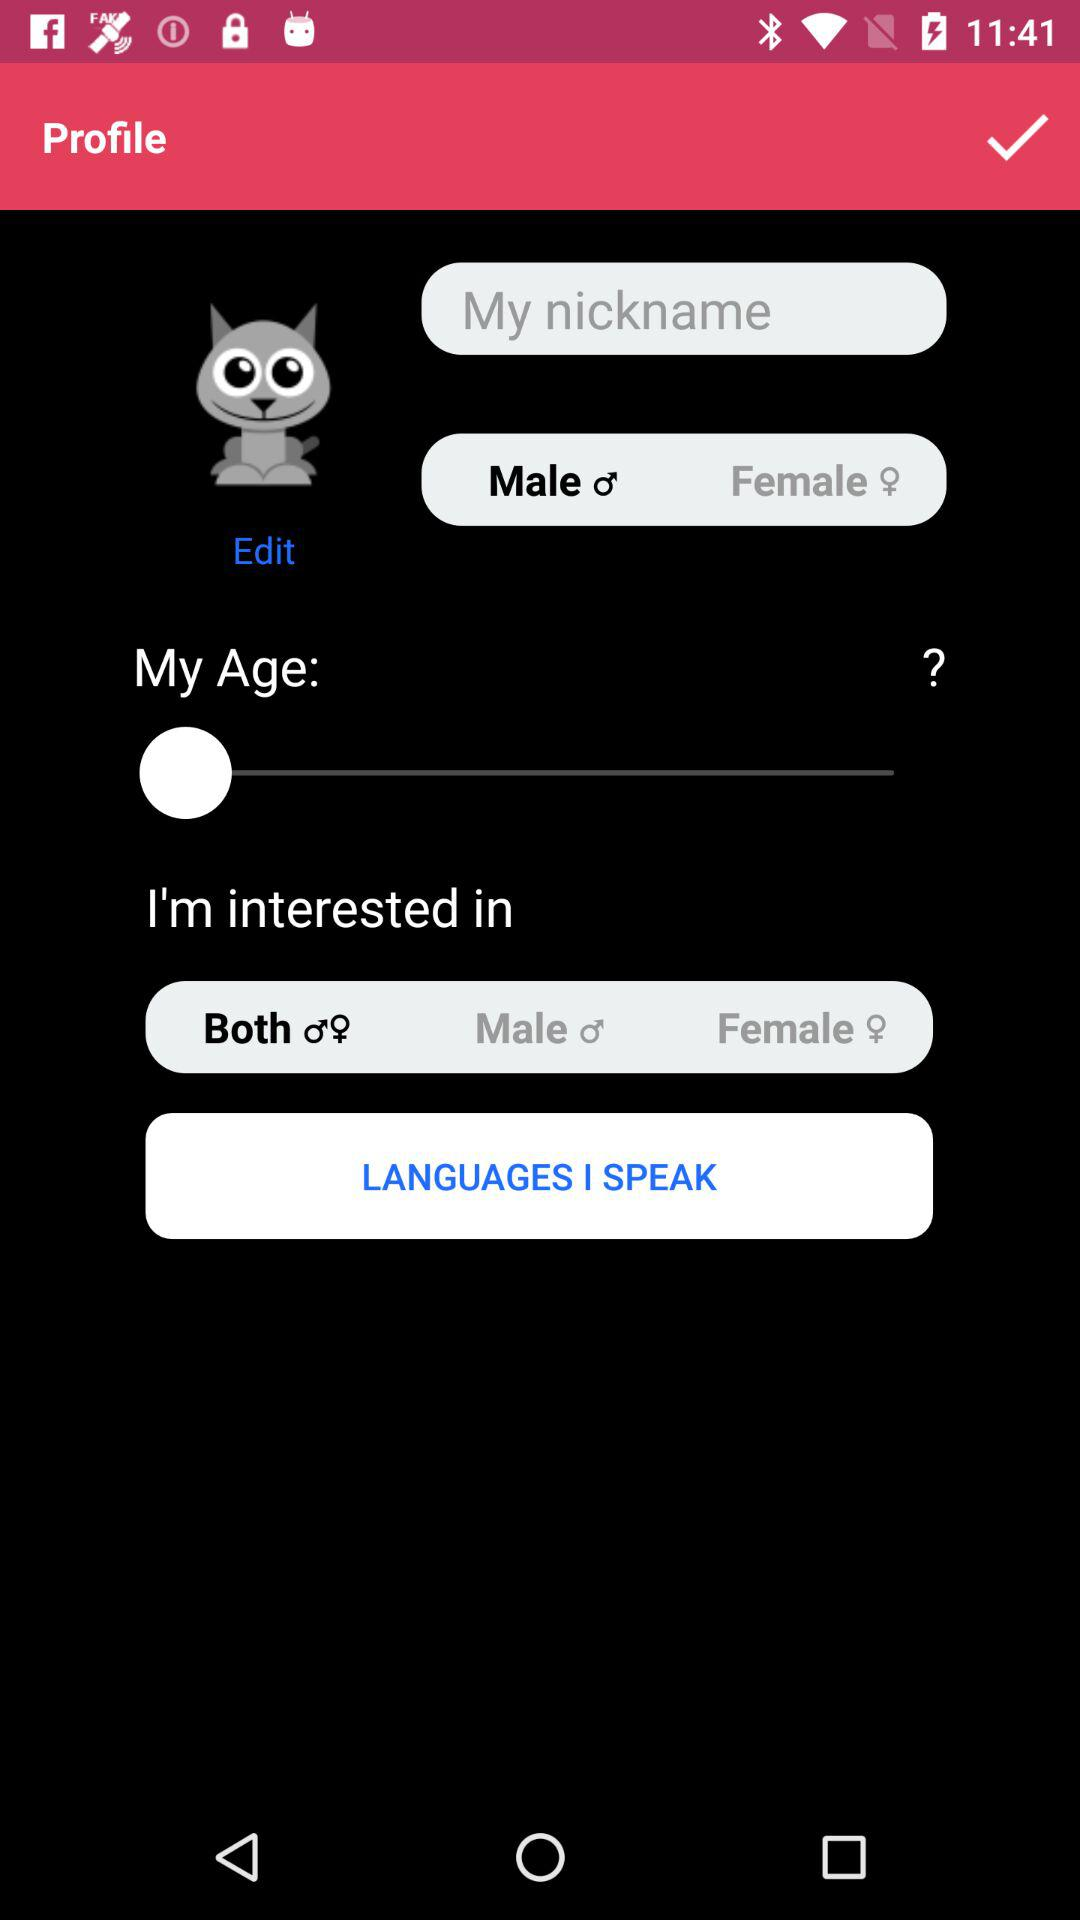What gender is selected? The selected gender is male. 